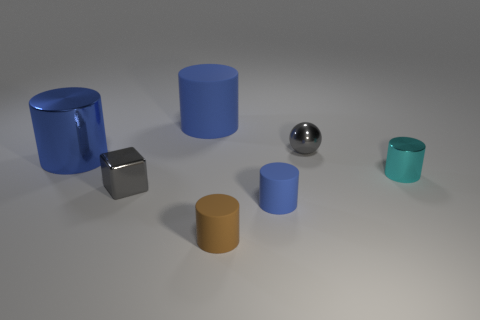Subtract all red cubes. How many blue cylinders are left? 3 Subtract 1 cylinders. How many cylinders are left? 4 Subtract all red cylinders. Subtract all red blocks. How many cylinders are left? 5 Add 1 small blue objects. How many objects exist? 8 Subtract all spheres. How many objects are left? 6 Subtract all big cyan objects. Subtract all tiny gray shiny blocks. How many objects are left? 6 Add 7 brown objects. How many brown objects are left? 8 Add 1 big red blocks. How many big red blocks exist? 1 Subtract 0 cyan balls. How many objects are left? 7 